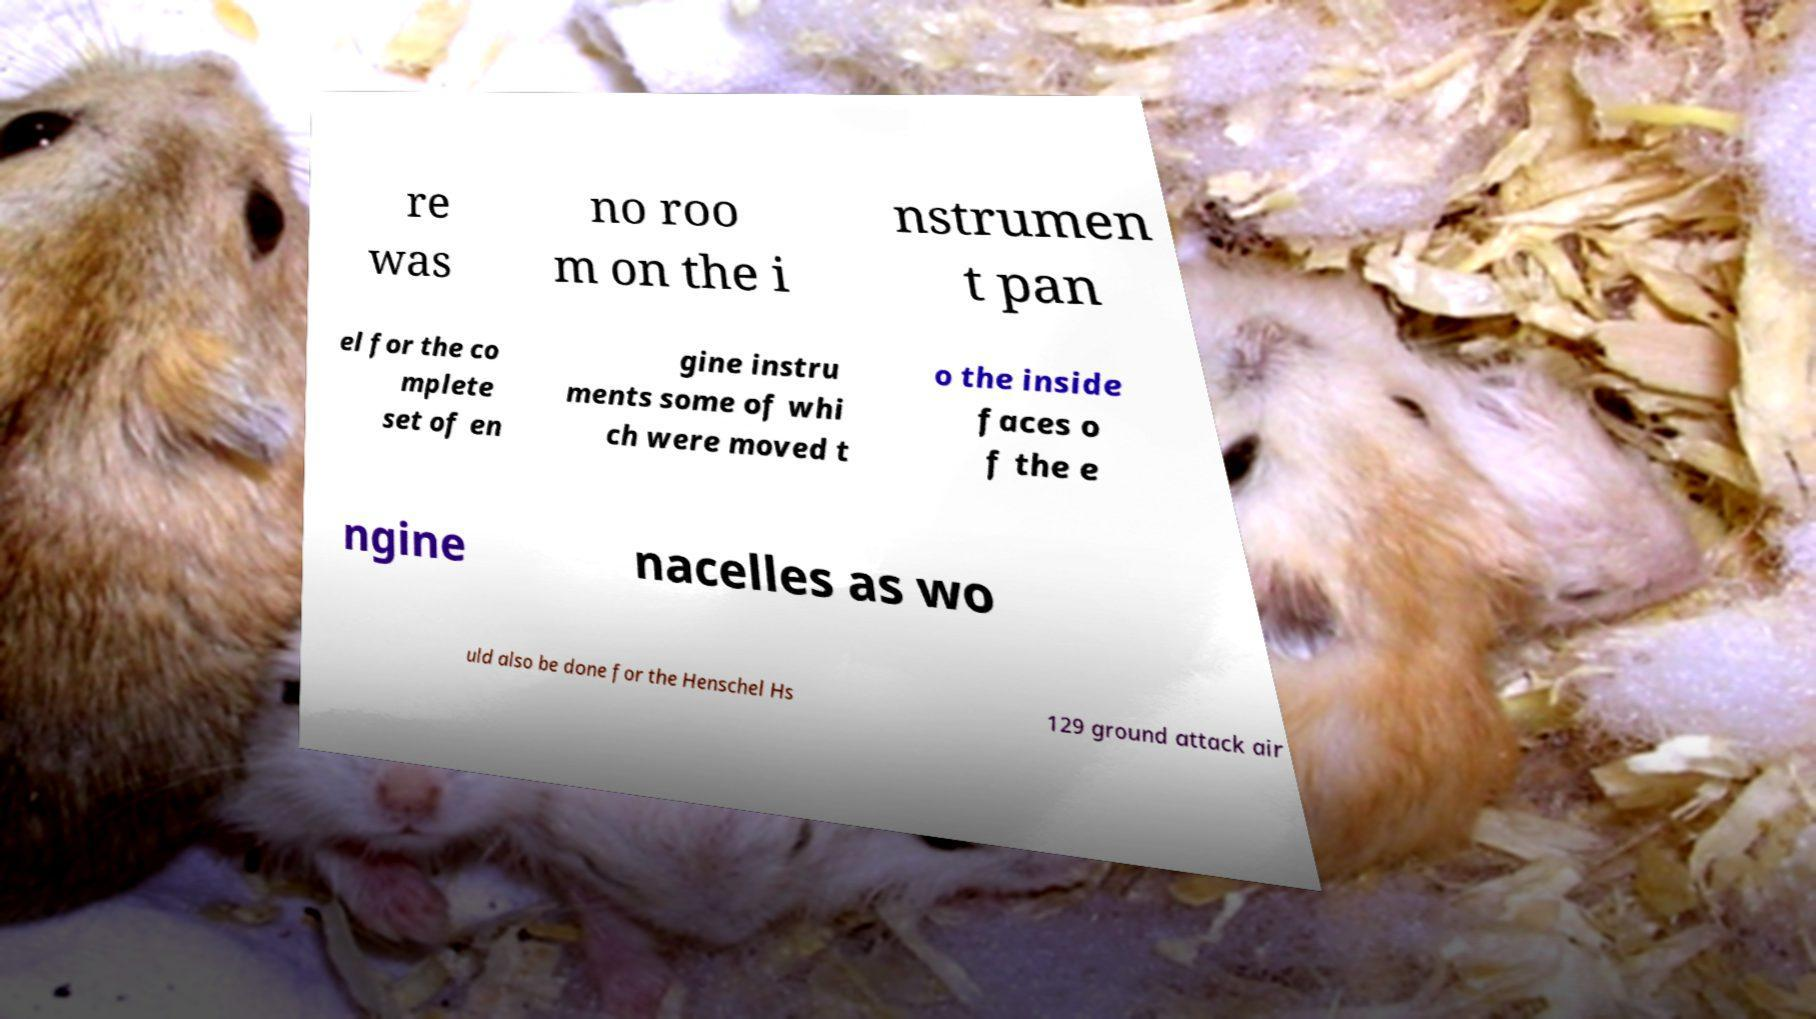Can you accurately transcribe the text from the provided image for me? re was no roo m on the i nstrumen t pan el for the co mplete set of en gine instru ments some of whi ch were moved t o the inside faces o f the e ngine nacelles as wo uld also be done for the Henschel Hs 129 ground attack air 